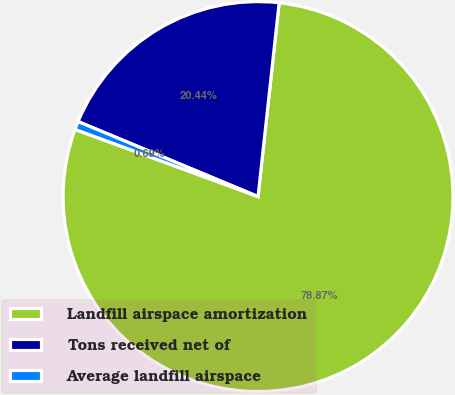Convert chart. <chart><loc_0><loc_0><loc_500><loc_500><pie_chart><fcel>Landfill airspace amortization<fcel>Tons received net of<fcel>Average landfill airspace<nl><fcel>78.87%<fcel>20.44%<fcel>0.69%<nl></chart> 